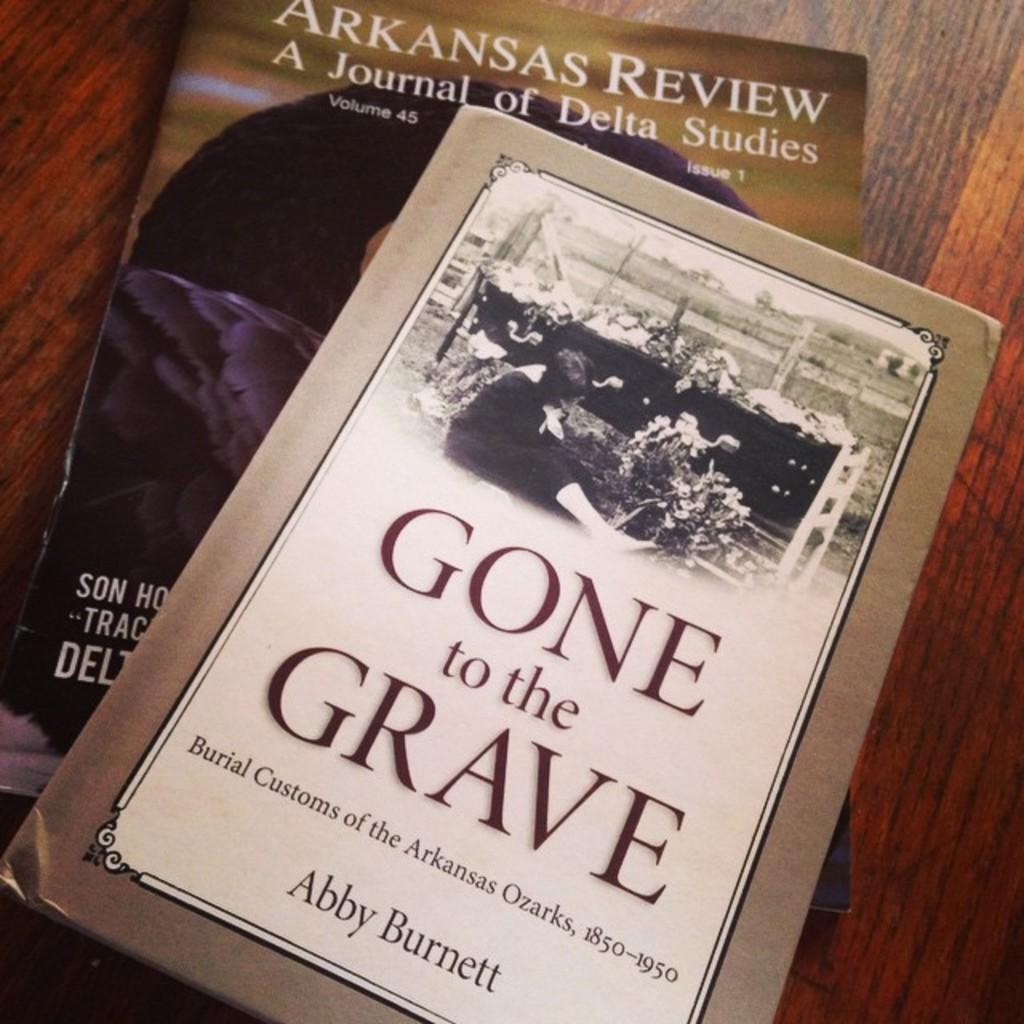<image>
Describe the image concisely. book titled gone to the grave on top of another book arkansas review 